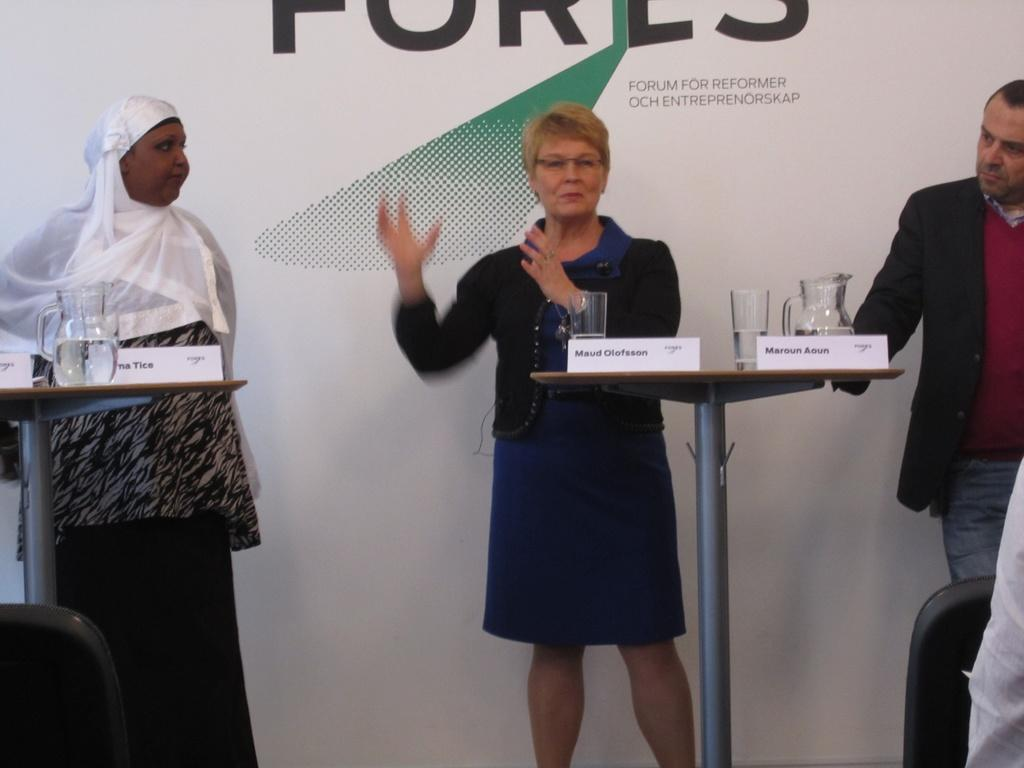How many people are in the image? There are three people in the image. Can you describe the gender of the people? Two of the people are women, and one is a man. What is in front of the people? There is a wooden desk in front of the people. What objects are on the wooden desk? There is a jar and a glass on the wooden desk. What type of creature is hiding behind the man in the image? There is no creature present in the image; it only features three people, a wooden desk, a jar, and a glass. 